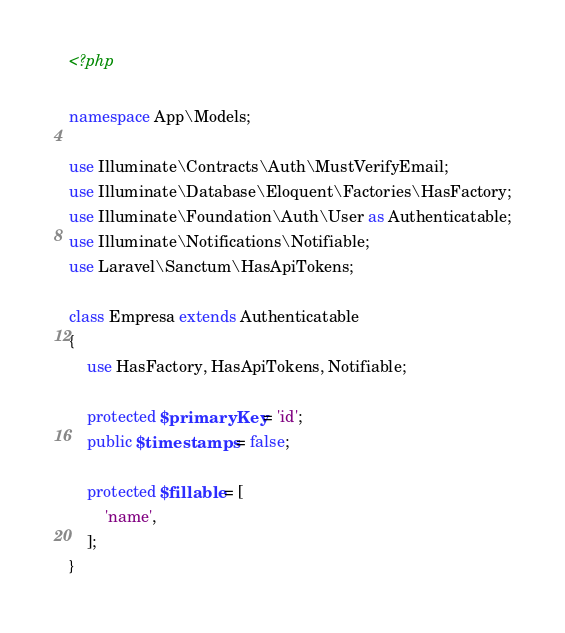<code> <loc_0><loc_0><loc_500><loc_500><_PHP_><?php

namespace App\Models;

use Illuminate\Contracts\Auth\MustVerifyEmail;
use Illuminate\Database\Eloquent\Factories\HasFactory;
use Illuminate\Foundation\Auth\User as Authenticatable;
use Illuminate\Notifications\Notifiable;
use Laravel\Sanctum\HasApiTokens;

class Empresa extends Authenticatable
{
    use HasFactory, HasApiTokens, Notifiable;

    protected $primaryKey = 'id';
    public $timestamps = false;

    protected $fillable = [
        'name',
    ];
}
</code> 